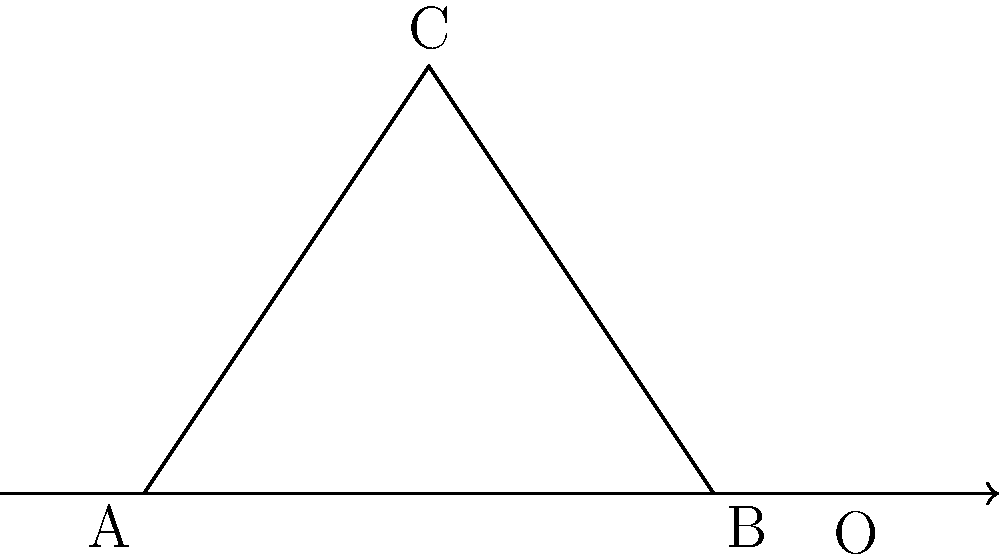In the recent local development project initiated by Ashish Kumar Chhabra, a triangular park ABC is being redesigned. The park has vertices A(0,0), B(4,0), and C(2,3). As part of the redesign, the park's layout will be reflected across the line x = 5. If the original area of the park is 6 square units, what will be the area of the reflected park A'B'C'? Let's approach this step-by-step:

1) First, we need to understand what reflection across a line means in terms of transformational geometry. When we reflect a shape across a line, the shape's size and angles remain the same, only its position changes.

2) In this case, we're reflecting across the line x = 5. This means that the distance of each point from the line x = 5 will remain the same after reflection, but on the opposite side of the line.

3) The important property to note here is that reflection preserves the shape and size of the original figure. This means that the area of the reflected triangle will be exactly the same as the area of the original triangle.

4) We're given that the original area of the park (triangle ABC) is 6 square units.

5) Since reflection preserves area, the area of the reflected park (triangle A'B'C') will also be 6 square units.

6) This result is independent of the actual coordinates of the reflected triangle. We don't need to calculate the new coordinates or use any area formulas.

Therefore, the area of the reflected park A'B'C' will be 6 square units, the same as the original park ABC.
Answer: 6 square units 